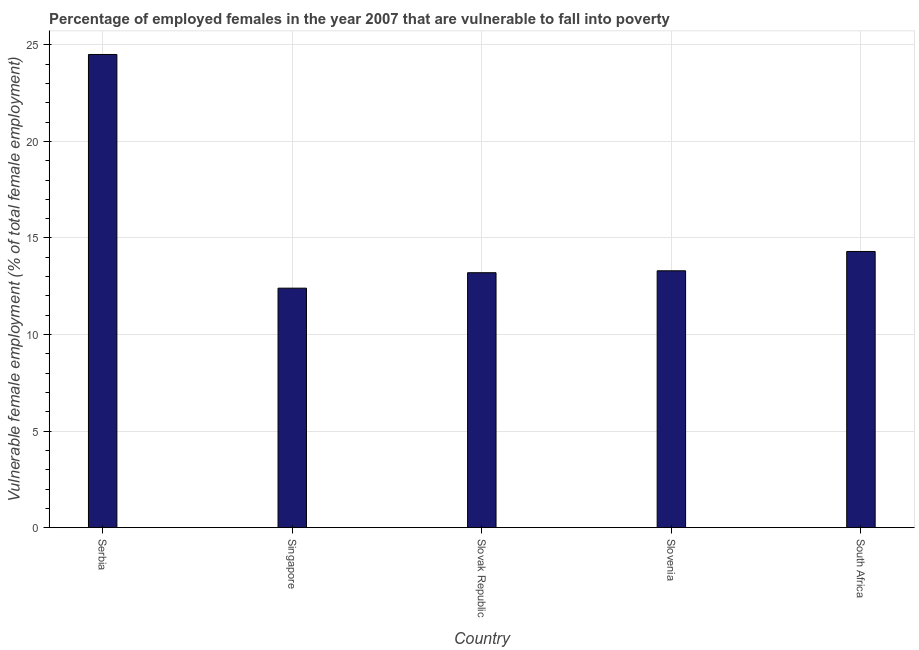Does the graph contain grids?
Your response must be concise. Yes. What is the title of the graph?
Offer a terse response. Percentage of employed females in the year 2007 that are vulnerable to fall into poverty. What is the label or title of the Y-axis?
Make the answer very short. Vulnerable female employment (% of total female employment). Across all countries, what is the minimum percentage of employed females who are vulnerable to fall into poverty?
Offer a terse response. 12.4. In which country was the percentage of employed females who are vulnerable to fall into poverty maximum?
Ensure brevity in your answer.  Serbia. In which country was the percentage of employed females who are vulnerable to fall into poverty minimum?
Your answer should be very brief. Singapore. What is the sum of the percentage of employed females who are vulnerable to fall into poverty?
Provide a succinct answer. 77.7. What is the difference between the percentage of employed females who are vulnerable to fall into poverty in Serbia and Slovak Republic?
Make the answer very short. 11.3. What is the average percentage of employed females who are vulnerable to fall into poverty per country?
Your response must be concise. 15.54. What is the median percentage of employed females who are vulnerable to fall into poverty?
Offer a very short reply. 13.3. In how many countries, is the percentage of employed females who are vulnerable to fall into poverty greater than 9 %?
Give a very brief answer. 5. What is the ratio of the percentage of employed females who are vulnerable to fall into poverty in Slovak Republic to that in South Africa?
Keep it short and to the point. 0.92. Is the difference between the percentage of employed females who are vulnerable to fall into poverty in Serbia and Slovenia greater than the difference between any two countries?
Give a very brief answer. No. How many bars are there?
Offer a terse response. 5. What is the difference between two consecutive major ticks on the Y-axis?
Provide a short and direct response. 5. Are the values on the major ticks of Y-axis written in scientific E-notation?
Make the answer very short. No. What is the Vulnerable female employment (% of total female employment) in Singapore?
Give a very brief answer. 12.4. What is the Vulnerable female employment (% of total female employment) of Slovak Republic?
Keep it short and to the point. 13.2. What is the Vulnerable female employment (% of total female employment) of Slovenia?
Make the answer very short. 13.3. What is the Vulnerable female employment (% of total female employment) in South Africa?
Give a very brief answer. 14.3. What is the difference between the Vulnerable female employment (% of total female employment) in Serbia and South Africa?
Your answer should be compact. 10.2. What is the difference between the Vulnerable female employment (% of total female employment) in Singapore and Slovenia?
Provide a succinct answer. -0.9. What is the difference between the Vulnerable female employment (% of total female employment) in Slovak Republic and Slovenia?
Provide a short and direct response. -0.1. What is the difference between the Vulnerable female employment (% of total female employment) in Slovenia and South Africa?
Provide a succinct answer. -1. What is the ratio of the Vulnerable female employment (% of total female employment) in Serbia to that in Singapore?
Keep it short and to the point. 1.98. What is the ratio of the Vulnerable female employment (% of total female employment) in Serbia to that in Slovak Republic?
Ensure brevity in your answer.  1.86. What is the ratio of the Vulnerable female employment (% of total female employment) in Serbia to that in Slovenia?
Offer a terse response. 1.84. What is the ratio of the Vulnerable female employment (% of total female employment) in Serbia to that in South Africa?
Your response must be concise. 1.71. What is the ratio of the Vulnerable female employment (% of total female employment) in Singapore to that in Slovak Republic?
Ensure brevity in your answer.  0.94. What is the ratio of the Vulnerable female employment (% of total female employment) in Singapore to that in Slovenia?
Your answer should be very brief. 0.93. What is the ratio of the Vulnerable female employment (% of total female employment) in Singapore to that in South Africa?
Ensure brevity in your answer.  0.87. What is the ratio of the Vulnerable female employment (% of total female employment) in Slovak Republic to that in South Africa?
Provide a short and direct response. 0.92. 